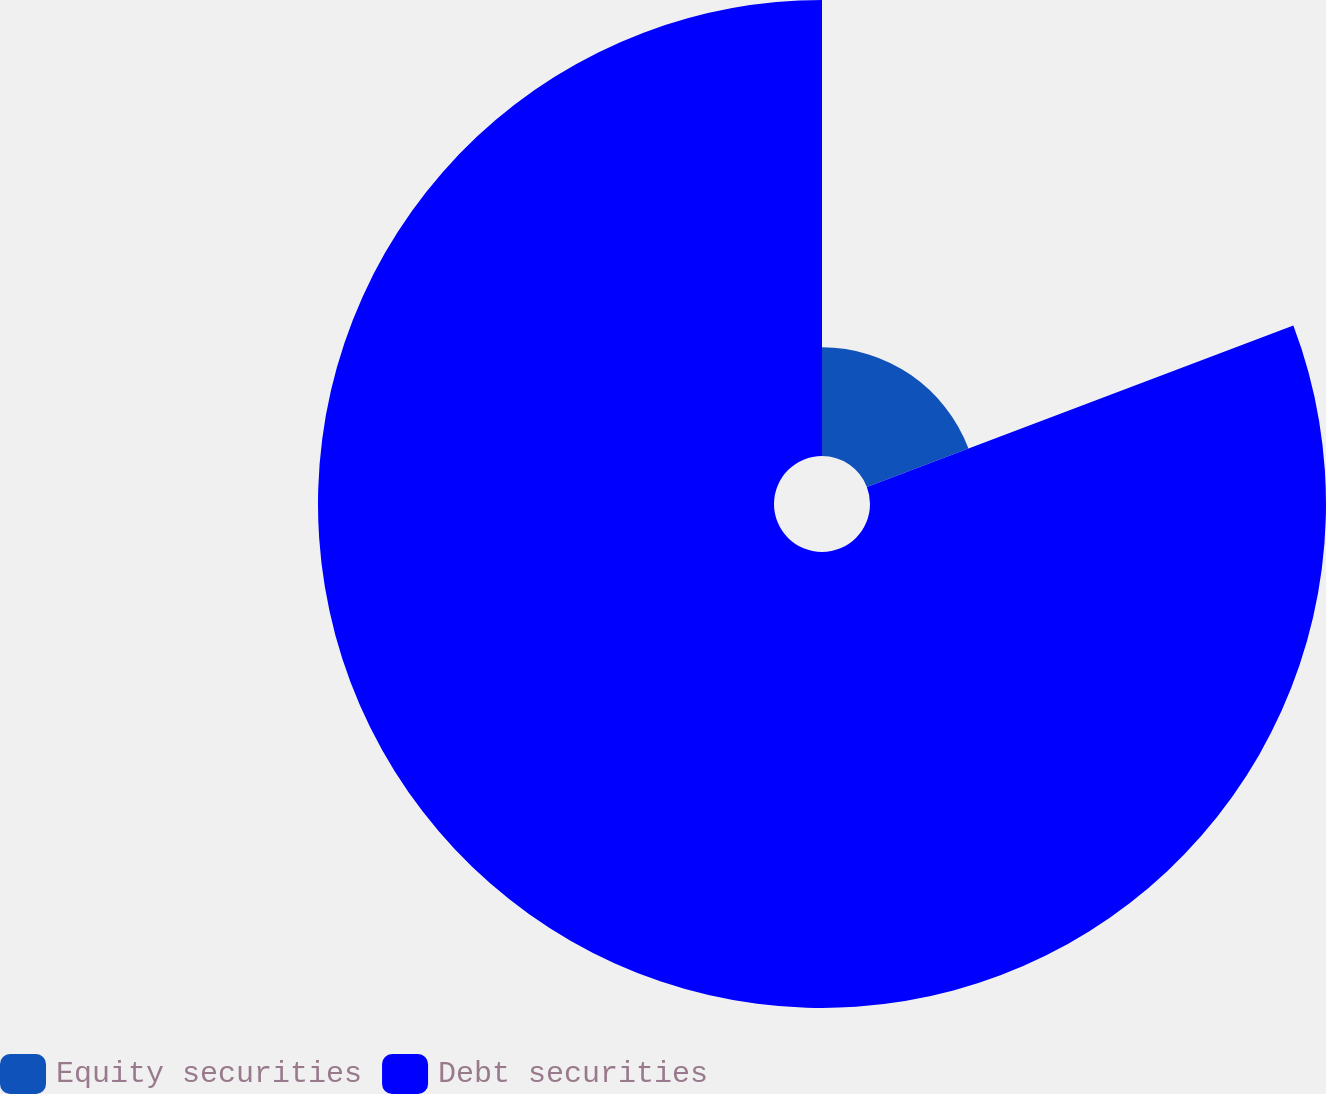Convert chart to OTSL. <chart><loc_0><loc_0><loc_500><loc_500><pie_chart><fcel>Equity securities<fcel>Debt securities<nl><fcel>19.24%<fcel>80.76%<nl></chart> 